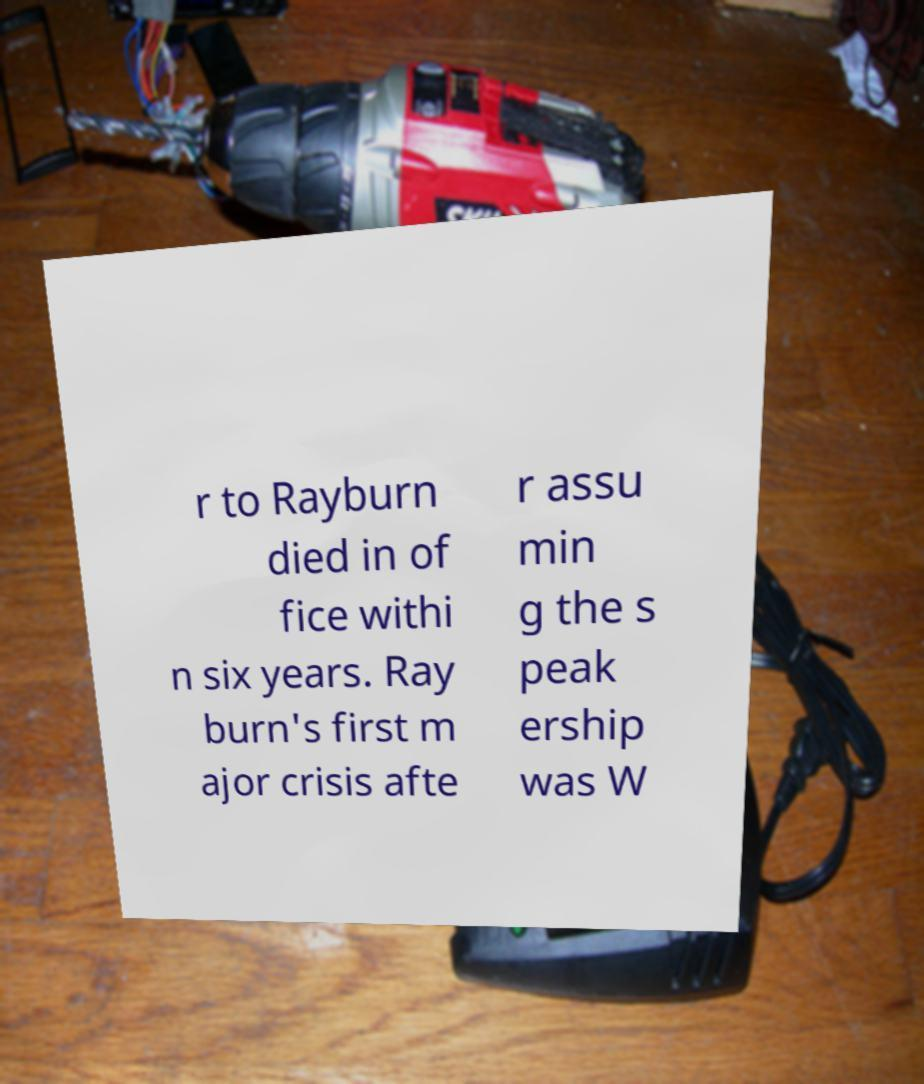Please read and relay the text visible in this image. What does it say? r to Rayburn died in of fice withi n six years. Ray burn's first m ajor crisis afte r assu min g the s peak ership was W 